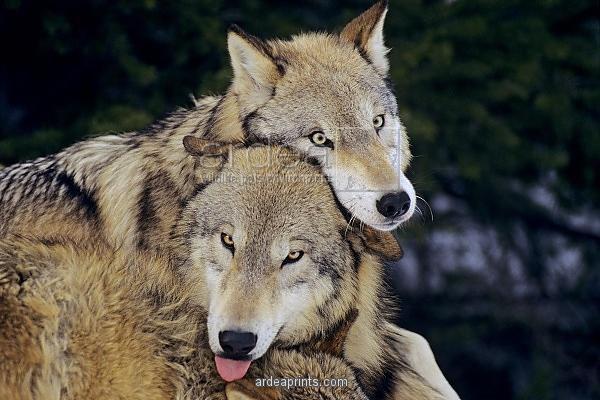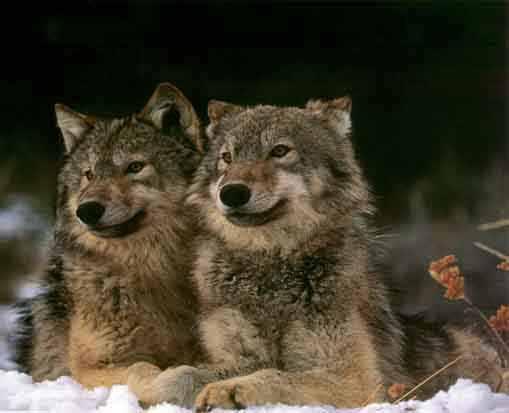The first image is the image on the left, the second image is the image on the right. Considering the images on both sides, is "The right image shows one wolf standing over another wolf that is lying on its back with its rear to the camera and multiple paws in the air." valid? Answer yes or no. No. 